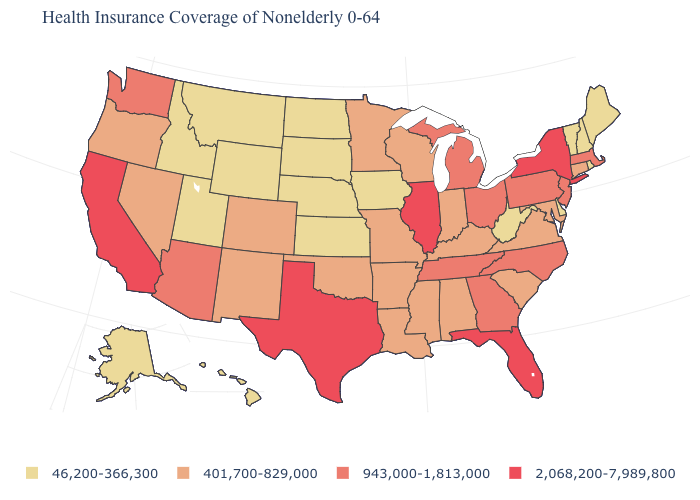Which states have the highest value in the USA?
Write a very short answer. California, Florida, Illinois, New York, Texas. What is the value of Idaho?
Keep it brief. 46,200-366,300. Name the states that have a value in the range 401,700-829,000?
Be succinct. Alabama, Arkansas, Colorado, Connecticut, Indiana, Kentucky, Louisiana, Maryland, Minnesota, Mississippi, Missouri, Nevada, New Mexico, Oklahoma, Oregon, South Carolina, Virginia, Wisconsin. Which states hav the highest value in the MidWest?
Quick response, please. Illinois. Which states have the lowest value in the USA?
Concise answer only. Alaska, Delaware, Hawaii, Idaho, Iowa, Kansas, Maine, Montana, Nebraska, New Hampshire, North Dakota, Rhode Island, South Dakota, Utah, Vermont, West Virginia, Wyoming. What is the lowest value in states that border Alabama?
Quick response, please. 401,700-829,000. Among the states that border Michigan , which have the lowest value?
Keep it brief. Indiana, Wisconsin. What is the value of North Carolina?
Be succinct. 943,000-1,813,000. Name the states that have a value in the range 2,068,200-7,989,800?
Keep it brief. California, Florida, Illinois, New York, Texas. Does Ohio have the same value as California?
Be succinct. No. Among the states that border Michigan , which have the highest value?
Short answer required. Ohio. Which states have the highest value in the USA?
Give a very brief answer. California, Florida, Illinois, New York, Texas. What is the lowest value in the USA?
Answer briefly. 46,200-366,300. Name the states that have a value in the range 2,068,200-7,989,800?
Quick response, please. California, Florida, Illinois, New York, Texas. Does the map have missing data?
Concise answer only. No. 